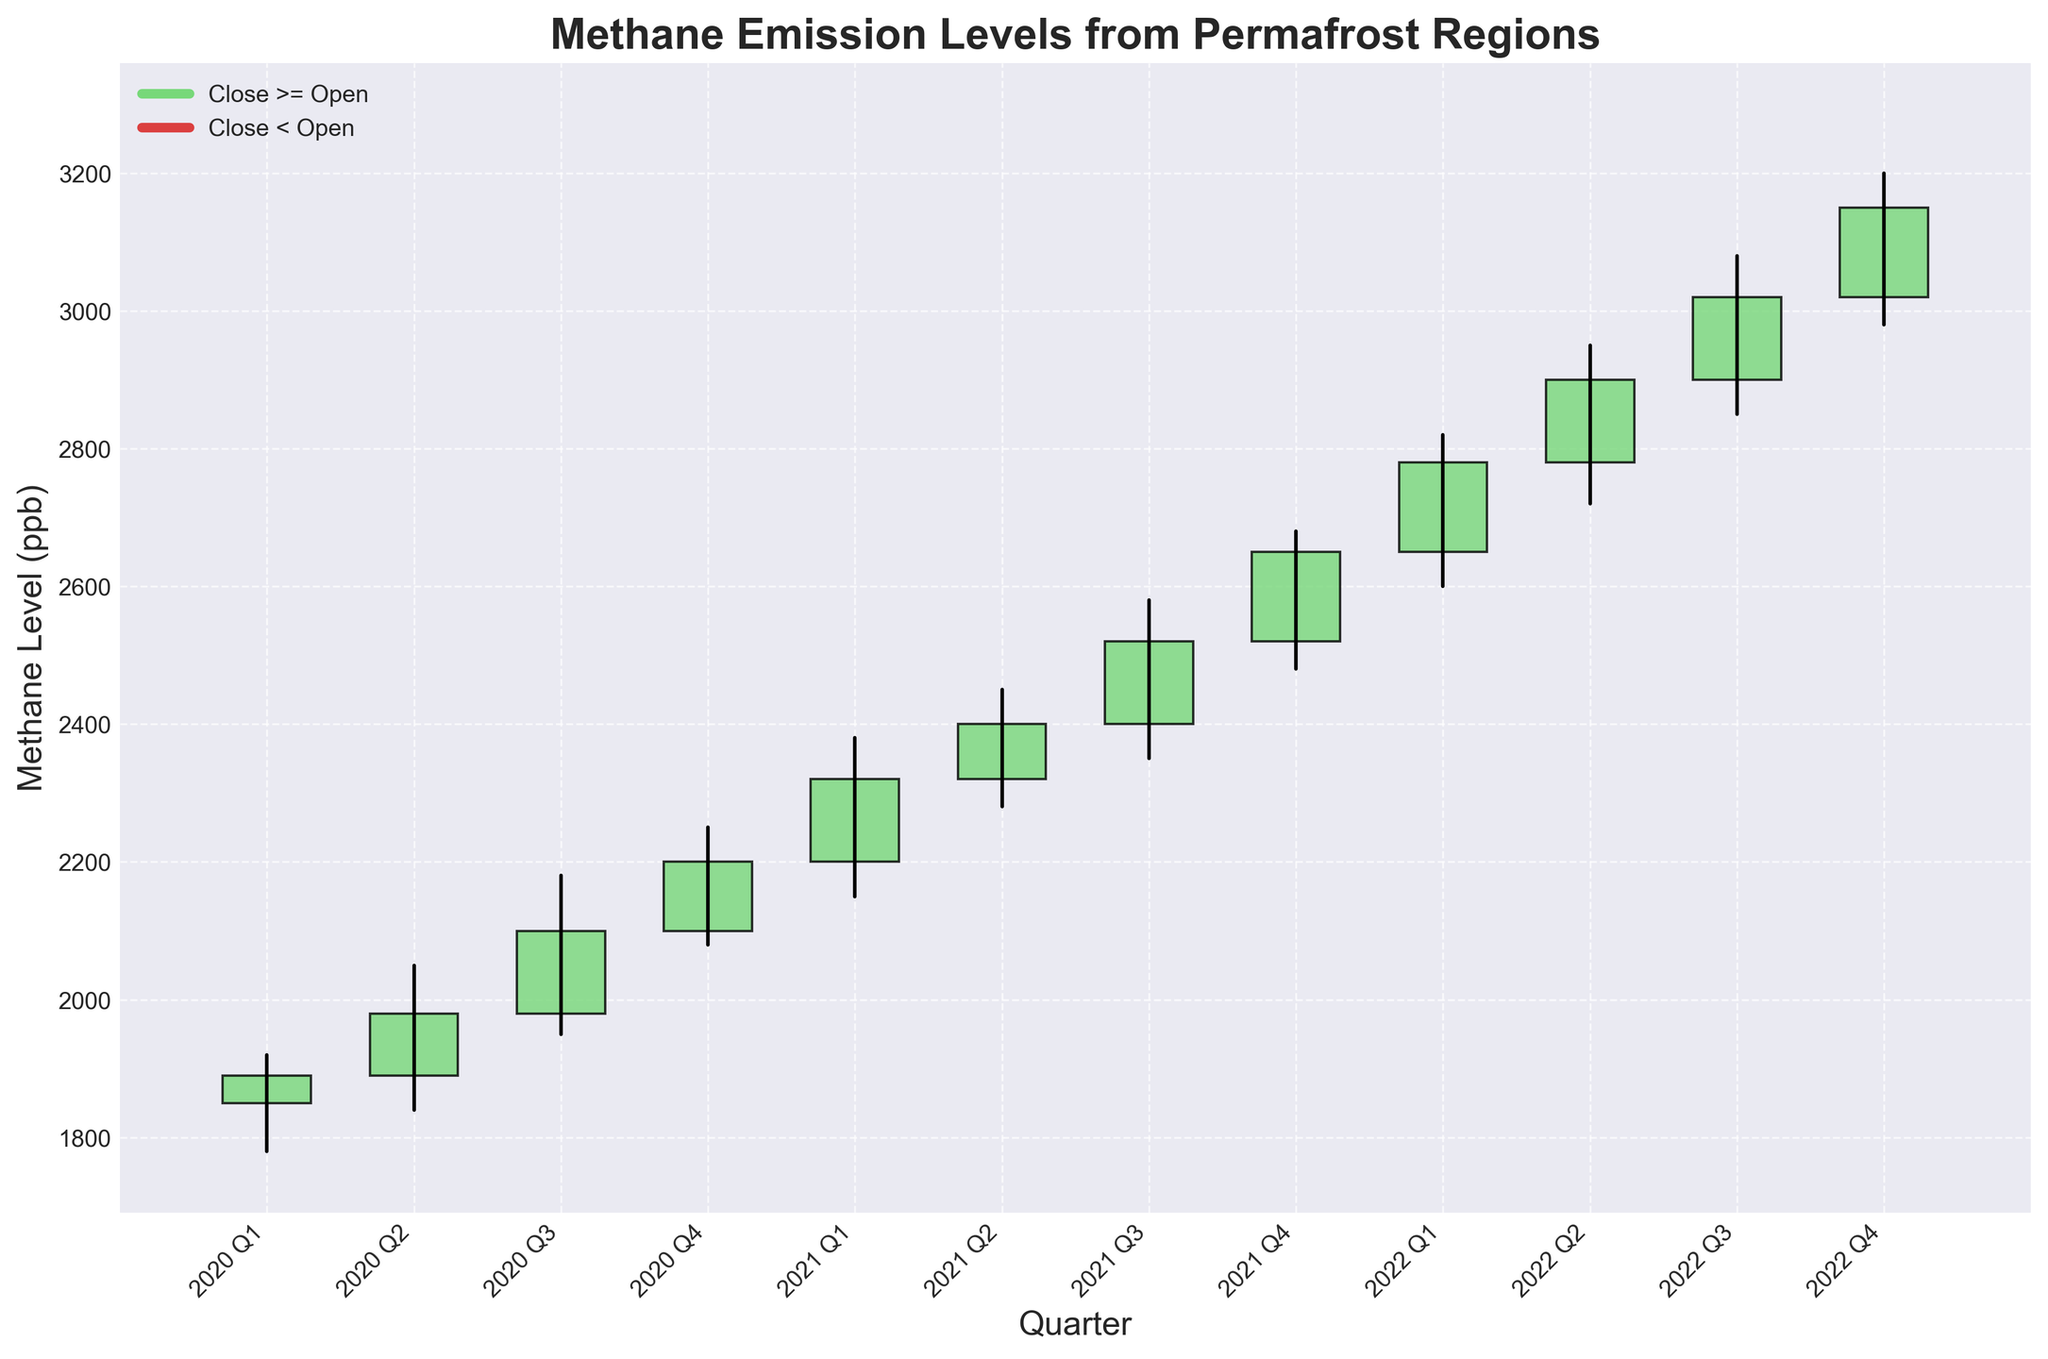Which quarter had the highest closing methane level? To find the quarter with the highest closing methane level, look at the 'Close' values for each quarter and identify the maximum value. The highest closing value is 3150 ppb in 2022 Q4.
Answer: 2022 Q4 Which quarter showed the largest quarterly increase in methane levels based on the closing values? To determine the largest quarterly increase, calculate the difference between the closing values of each consecutive quarter and identify the maximum increase. The largest increase is between 2020 Q4 (2200) and 2021 Q1 (2320), which is an increase of 120 ppb.
Answer: 2020 Q4 to 2021 Q1 What is the general trend in methane emission levels from 2020 Q1 to 2022 Q4? To identify the general trend, observe the closing values from the first quarter of 2020 to the last quarter of 2022. The values show a consistent upward trend from 1850 ppb to 3150 ppb over the specified period.
Answer: Upward trend Which quarter had the smallest range (difference between high and low) in methane levels? Calculate the range for each quarter by subtracting the 'Low' value from the 'High' value and identifying the smallest result. The smallest range is 2022 Q4, with a difference of 220 (3200 - 2980).
Answer: 2022 Q4 Between which consecutive quarters did the methane levels drop, looking at the closing values? Compare the closing values of each consecutive quarter and check where the closing value in a quarter is lower than the previous one. The drop occurred from 2020 Q1 (1890) to 2020 Q2 (1980) as the only downward trend.
Answer: 2020 Q1 to 2020 Q2 What was the opening value of methane levels in 2021 Q3? To find the opening value for 2021 Q3, refer to the 'Open' column for that quarter. The opening value for 2021 Q3 is 2400 ppb.
Answer: 2400 ppb Which quarter had the highest high value, and what was it? Look at the 'High' column to find the maximum value and the corresponding quarter. The highest high value is 3200 ppb in 2022 Q4.
Answer: 2022 Q4 Calculate the average closing value for the year 2021. Sum the closing values for each quarter of 2021 and divide by 4: (2320 + 2400 + 2520 + 2650) / 4 = 2472.5 ppb.
Answer: 2472.5 ppb In which quarter did the opening value exceed 2100 ppb for the first time? Identify the first quarter where the 'Open' value is more than 2100 ppb. The first such quarter is 2021 Q1 with an opening value of 2200 ppb.
Answer: 2021 Q1 